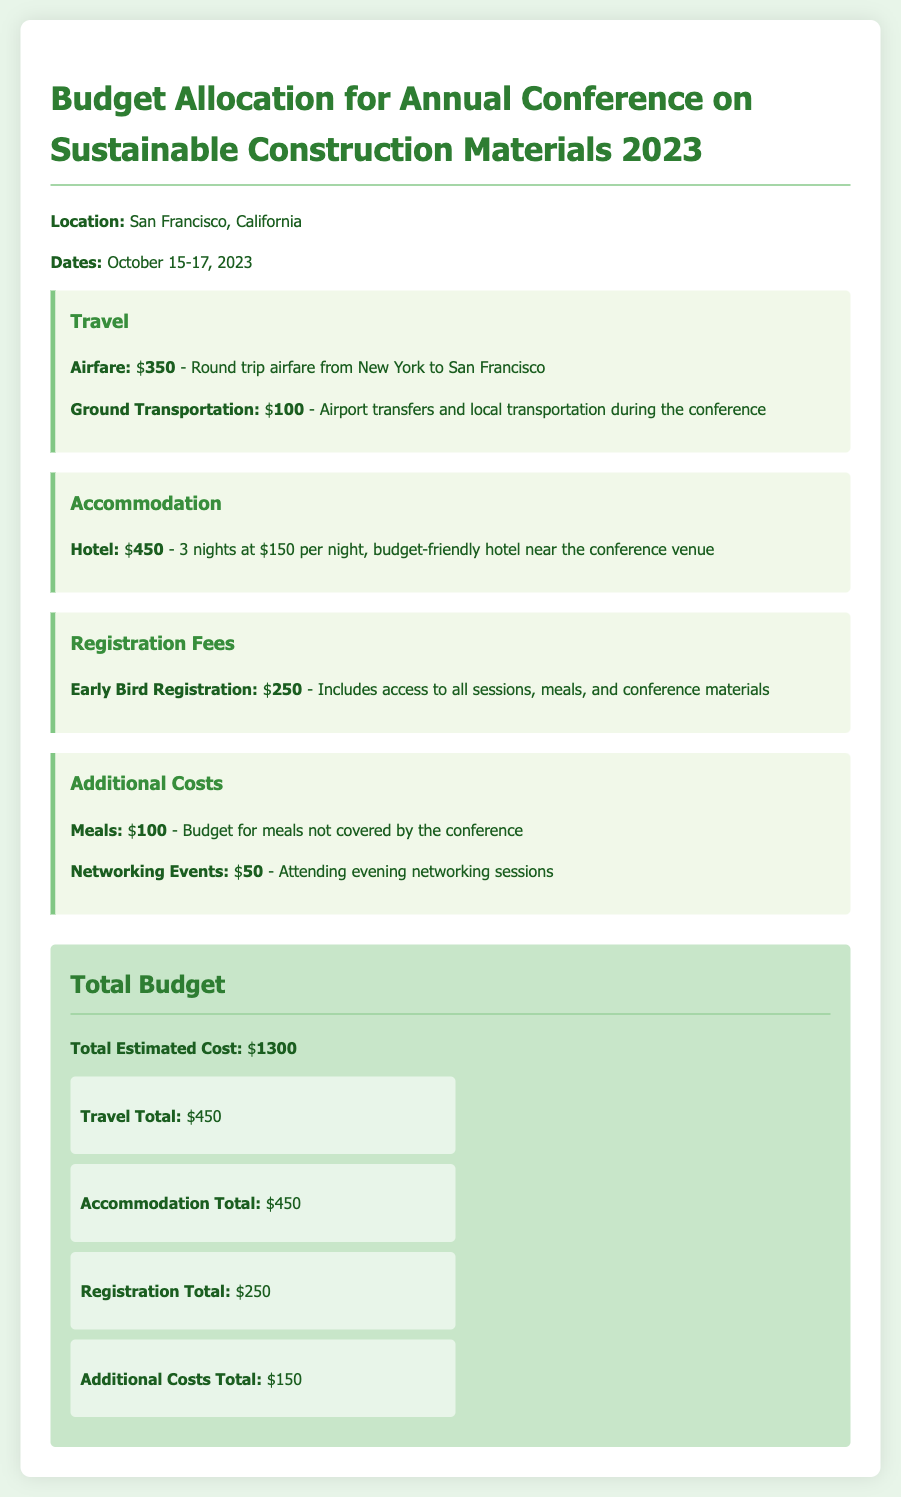what is the location of the conference? The location of the conference is mentioned in the document as San Francisco, California.
Answer: San Francisco, California what are the conference dates? The dates of the conference are clearly stated in the document as October 15-17, 2023.
Answer: October 15-17, 2023 how much is the airfare? The document specifies the airfare cost for the round trip from New York to San Francisco as $350.
Answer: $350 what is the total estimated cost? The document lists the total estimated cost for the conference as $1300, which is the sum of all budget items.
Answer: $1300 how many nights is the accommodation budgeted for? The accommodation section indicates that the budget is for 3 nights at a hotel.
Answer: 3 nights what is the cost allocated for meals? The budget allocates $100 for meals not covered by the conference.
Answer: $100 what is included in the early bird registration? The document states that early bird registration includes access to all sessions, meals, and conference materials.
Answer: Access to all sessions, meals, and conference materials what is the total budget for travel? The travel total is specified as $450, which includes both airfare and ground transportation.
Answer: $450 how much is allocated for networking events? The budget specifies an allocation of $50 for attending evening networking sessions.
Answer: $50 